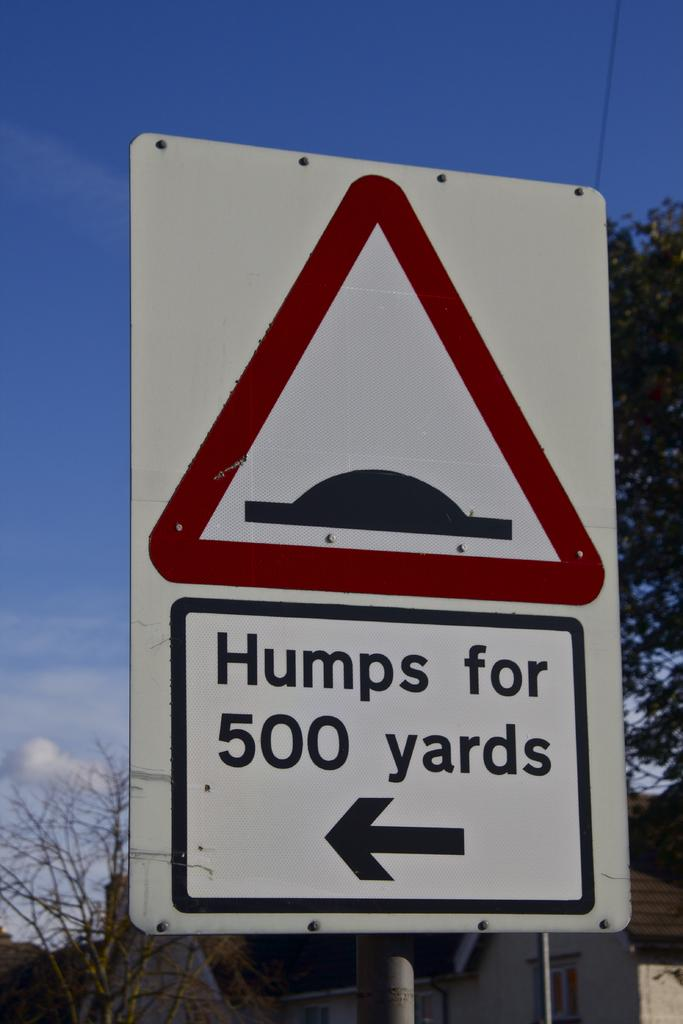<image>
Create a compact narrative representing the image presented. The sign indicates that there are humps for the next 500 yards. 